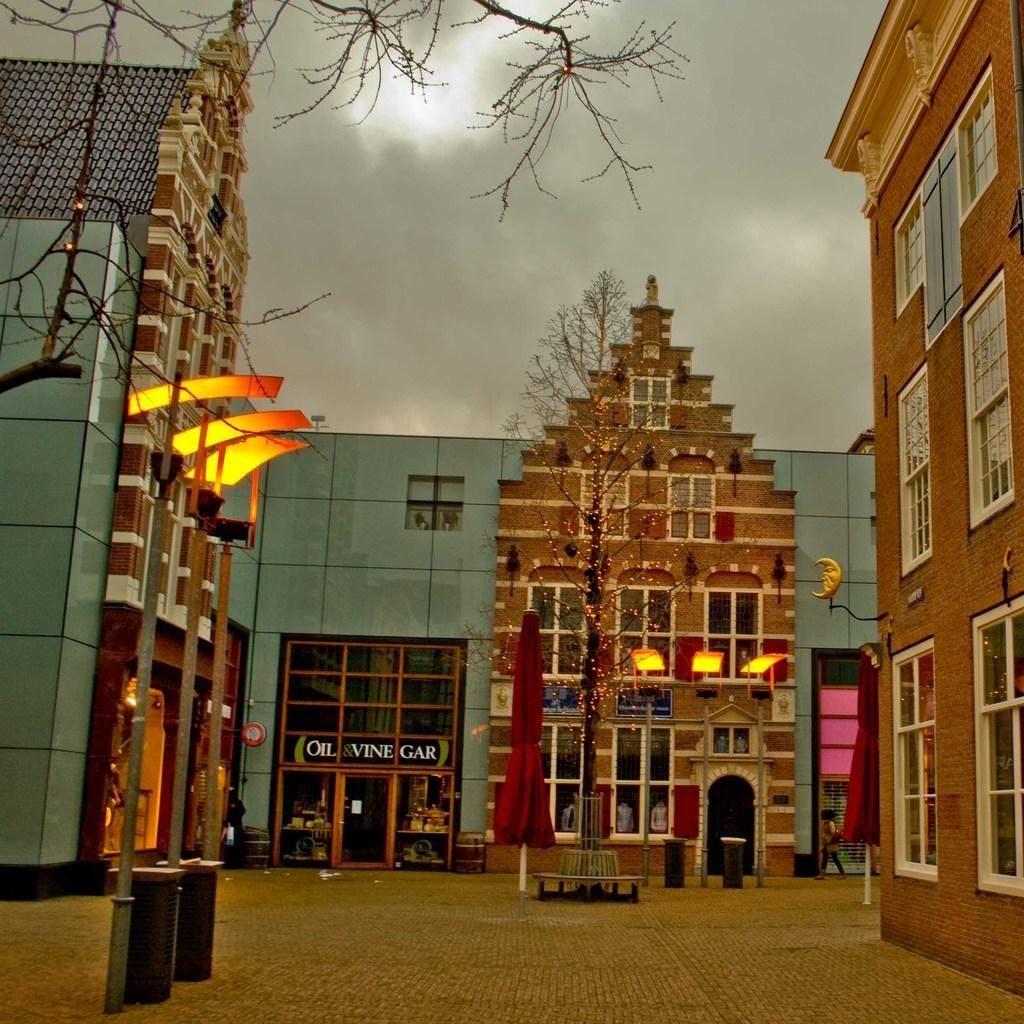What type of structures can be seen in the image? There are buildings and stores in the image. What else is present in the image besides structures? There are trees in the image. How would you describe the weather in the image? The sky is cloudy in the image. What can be seen illuminating the scene in the image? There are lights in the image. What type of silk is being used to decorate the stores in the image? There is no silk present in the image; it only features buildings, stores, trees, a cloudy sky, and lights. 